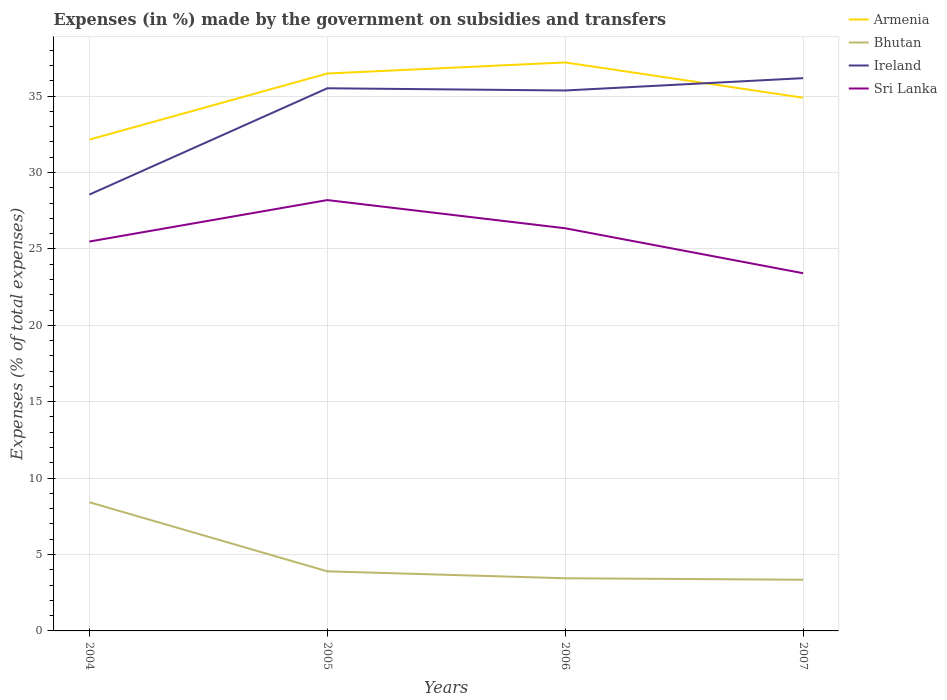How many different coloured lines are there?
Provide a succinct answer. 4. Does the line corresponding to Sri Lanka intersect with the line corresponding to Armenia?
Ensure brevity in your answer.  No. Is the number of lines equal to the number of legend labels?
Give a very brief answer. Yes. Across all years, what is the maximum percentage of expenses made by the government on subsidies and transfers in Ireland?
Provide a succinct answer. 28.56. In which year was the percentage of expenses made by the government on subsidies and transfers in Ireland maximum?
Provide a short and direct response. 2004. What is the total percentage of expenses made by the government on subsidies and transfers in Armenia in the graph?
Ensure brevity in your answer.  -2.74. What is the difference between the highest and the second highest percentage of expenses made by the government on subsidies and transfers in Bhutan?
Your answer should be very brief. 5.07. How many lines are there?
Give a very brief answer. 4. How many years are there in the graph?
Provide a short and direct response. 4. Does the graph contain any zero values?
Your response must be concise. No. Does the graph contain grids?
Your answer should be very brief. Yes. Where does the legend appear in the graph?
Offer a terse response. Top right. How many legend labels are there?
Your answer should be compact. 4. What is the title of the graph?
Keep it short and to the point. Expenses (in %) made by the government on subsidies and transfers. What is the label or title of the X-axis?
Ensure brevity in your answer.  Years. What is the label or title of the Y-axis?
Your answer should be compact. Expenses (% of total expenses). What is the Expenses (% of total expenses) of Armenia in 2004?
Your response must be concise. 32.15. What is the Expenses (% of total expenses) of Bhutan in 2004?
Give a very brief answer. 8.42. What is the Expenses (% of total expenses) of Ireland in 2004?
Offer a terse response. 28.56. What is the Expenses (% of total expenses) in Sri Lanka in 2004?
Your response must be concise. 25.48. What is the Expenses (% of total expenses) in Armenia in 2005?
Your response must be concise. 36.48. What is the Expenses (% of total expenses) in Bhutan in 2005?
Your answer should be compact. 3.9. What is the Expenses (% of total expenses) in Ireland in 2005?
Make the answer very short. 35.51. What is the Expenses (% of total expenses) in Sri Lanka in 2005?
Make the answer very short. 28.2. What is the Expenses (% of total expenses) in Armenia in 2006?
Offer a terse response. 37.2. What is the Expenses (% of total expenses) of Bhutan in 2006?
Offer a terse response. 3.45. What is the Expenses (% of total expenses) of Ireland in 2006?
Your answer should be very brief. 35.37. What is the Expenses (% of total expenses) of Sri Lanka in 2006?
Keep it short and to the point. 26.35. What is the Expenses (% of total expenses) of Armenia in 2007?
Give a very brief answer. 34.89. What is the Expenses (% of total expenses) in Bhutan in 2007?
Offer a terse response. 3.35. What is the Expenses (% of total expenses) in Ireland in 2007?
Offer a very short reply. 36.18. What is the Expenses (% of total expenses) in Sri Lanka in 2007?
Provide a succinct answer. 23.41. Across all years, what is the maximum Expenses (% of total expenses) in Armenia?
Make the answer very short. 37.2. Across all years, what is the maximum Expenses (% of total expenses) of Bhutan?
Give a very brief answer. 8.42. Across all years, what is the maximum Expenses (% of total expenses) of Ireland?
Provide a short and direct response. 36.18. Across all years, what is the maximum Expenses (% of total expenses) of Sri Lanka?
Offer a very short reply. 28.2. Across all years, what is the minimum Expenses (% of total expenses) of Armenia?
Your answer should be compact. 32.15. Across all years, what is the minimum Expenses (% of total expenses) of Bhutan?
Make the answer very short. 3.35. Across all years, what is the minimum Expenses (% of total expenses) in Ireland?
Provide a short and direct response. 28.56. Across all years, what is the minimum Expenses (% of total expenses) of Sri Lanka?
Offer a very short reply. 23.41. What is the total Expenses (% of total expenses) of Armenia in the graph?
Provide a short and direct response. 140.73. What is the total Expenses (% of total expenses) in Bhutan in the graph?
Give a very brief answer. 19.12. What is the total Expenses (% of total expenses) of Ireland in the graph?
Your answer should be compact. 135.62. What is the total Expenses (% of total expenses) of Sri Lanka in the graph?
Provide a succinct answer. 103.44. What is the difference between the Expenses (% of total expenses) of Armenia in 2004 and that in 2005?
Offer a terse response. -4.33. What is the difference between the Expenses (% of total expenses) in Bhutan in 2004 and that in 2005?
Your answer should be compact. 4.52. What is the difference between the Expenses (% of total expenses) in Ireland in 2004 and that in 2005?
Offer a very short reply. -6.96. What is the difference between the Expenses (% of total expenses) in Sri Lanka in 2004 and that in 2005?
Give a very brief answer. -2.71. What is the difference between the Expenses (% of total expenses) in Armenia in 2004 and that in 2006?
Your response must be concise. -5.05. What is the difference between the Expenses (% of total expenses) in Bhutan in 2004 and that in 2006?
Your response must be concise. 4.98. What is the difference between the Expenses (% of total expenses) in Ireland in 2004 and that in 2006?
Provide a short and direct response. -6.81. What is the difference between the Expenses (% of total expenses) in Sri Lanka in 2004 and that in 2006?
Ensure brevity in your answer.  -0.87. What is the difference between the Expenses (% of total expenses) in Armenia in 2004 and that in 2007?
Your answer should be compact. -2.74. What is the difference between the Expenses (% of total expenses) of Bhutan in 2004 and that in 2007?
Give a very brief answer. 5.07. What is the difference between the Expenses (% of total expenses) in Ireland in 2004 and that in 2007?
Provide a short and direct response. -7.62. What is the difference between the Expenses (% of total expenses) in Sri Lanka in 2004 and that in 2007?
Your answer should be compact. 2.07. What is the difference between the Expenses (% of total expenses) of Armenia in 2005 and that in 2006?
Provide a succinct answer. -0.73. What is the difference between the Expenses (% of total expenses) in Bhutan in 2005 and that in 2006?
Your answer should be very brief. 0.45. What is the difference between the Expenses (% of total expenses) of Ireland in 2005 and that in 2006?
Keep it short and to the point. 0.14. What is the difference between the Expenses (% of total expenses) of Sri Lanka in 2005 and that in 2006?
Offer a very short reply. 1.84. What is the difference between the Expenses (% of total expenses) in Armenia in 2005 and that in 2007?
Provide a short and direct response. 1.58. What is the difference between the Expenses (% of total expenses) in Bhutan in 2005 and that in 2007?
Keep it short and to the point. 0.55. What is the difference between the Expenses (% of total expenses) in Ireland in 2005 and that in 2007?
Keep it short and to the point. -0.66. What is the difference between the Expenses (% of total expenses) in Sri Lanka in 2005 and that in 2007?
Offer a very short reply. 4.79. What is the difference between the Expenses (% of total expenses) of Armenia in 2006 and that in 2007?
Offer a very short reply. 2.31. What is the difference between the Expenses (% of total expenses) of Bhutan in 2006 and that in 2007?
Make the answer very short. 0.1. What is the difference between the Expenses (% of total expenses) in Ireland in 2006 and that in 2007?
Your answer should be very brief. -0.81. What is the difference between the Expenses (% of total expenses) in Sri Lanka in 2006 and that in 2007?
Your response must be concise. 2.94. What is the difference between the Expenses (% of total expenses) in Armenia in 2004 and the Expenses (% of total expenses) in Bhutan in 2005?
Give a very brief answer. 28.25. What is the difference between the Expenses (% of total expenses) in Armenia in 2004 and the Expenses (% of total expenses) in Ireland in 2005?
Give a very brief answer. -3.36. What is the difference between the Expenses (% of total expenses) in Armenia in 2004 and the Expenses (% of total expenses) in Sri Lanka in 2005?
Your answer should be very brief. 3.96. What is the difference between the Expenses (% of total expenses) in Bhutan in 2004 and the Expenses (% of total expenses) in Ireland in 2005?
Provide a short and direct response. -27.09. What is the difference between the Expenses (% of total expenses) of Bhutan in 2004 and the Expenses (% of total expenses) of Sri Lanka in 2005?
Ensure brevity in your answer.  -19.77. What is the difference between the Expenses (% of total expenses) in Ireland in 2004 and the Expenses (% of total expenses) in Sri Lanka in 2005?
Offer a terse response. 0.36. What is the difference between the Expenses (% of total expenses) of Armenia in 2004 and the Expenses (% of total expenses) of Bhutan in 2006?
Make the answer very short. 28.71. What is the difference between the Expenses (% of total expenses) of Armenia in 2004 and the Expenses (% of total expenses) of Ireland in 2006?
Give a very brief answer. -3.22. What is the difference between the Expenses (% of total expenses) in Armenia in 2004 and the Expenses (% of total expenses) in Sri Lanka in 2006?
Give a very brief answer. 5.8. What is the difference between the Expenses (% of total expenses) in Bhutan in 2004 and the Expenses (% of total expenses) in Ireland in 2006?
Your response must be concise. -26.95. What is the difference between the Expenses (% of total expenses) in Bhutan in 2004 and the Expenses (% of total expenses) in Sri Lanka in 2006?
Your response must be concise. -17.93. What is the difference between the Expenses (% of total expenses) of Ireland in 2004 and the Expenses (% of total expenses) of Sri Lanka in 2006?
Your answer should be very brief. 2.21. What is the difference between the Expenses (% of total expenses) in Armenia in 2004 and the Expenses (% of total expenses) in Bhutan in 2007?
Offer a very short reply. 28.8. What is the difference between the Expenses (% of total expenses) in Armenia in 2004 and the Expenses (% of total expenses) in Ireland in 2007?
Your answer should be very brief. -4.02. What is the difference between the Expenses (% of total expenses) of Armenia in 2004 and the Expenses (% of total expenses) of Sri Lanka in 2007?
Give a very brief answer. 8.74. What is the difference between the Expenses (% of total expenses) in Bhutan in 2004 and the Expenses (% of total expenses) in Ireland in 2007?
Make the answer very short. -27.75. What is the difference between the Expenses (% of total expenses) of Bhutan in 2004 and the Expenses (% of total expenses) of Sri Lanka in 2007?
Provide a succinct answer. -14.99. What is the difference between the Expenses (% of total expenses) in Ireland in 2004 and the Expenses (% of total expenses) in Sri Lanka in 2007?
Ensure brevity in your answer.  5.15. What is the difference between the Expenses (% of total expenses) of Armenia in 2005 and the Expenses (% of total expenses) of Bhutan in 2006?
Offer a terse response. 33.03. What is the difference between the Expenses (% of total expenses) in Armenia in 2005 and the Expenses (% of total expenses) in Ireland in 2006?
Your answer should be very brief. 1.11. What is the difference between the Expenses (% of total expenses) in Armenia in 2005 and the Expenses (% of total expenses) in Sri Lanka in 2006?
Keep it short and to the point. 10.13. What is the difference between the Expenses (% of total expenses) of Bhutan in 2005 and the Expenses (% of total expenses) of Ireland in 2006?
Make the answer very short. -31.47. What is the difference between the Expenses (% of total expenses) of Bhutan in 2005 and the Expenses (% of total expenses) of Sri Lanka in 2006?
Your response must be concise. -22.45. What is the difference between the Expenses (% of total expenses) in Ireland in 2005 and the Expenses (% of total expenses) in Sri Lanka in 2006?
Make the answer very short. 9.16. What is the difference between the Expenses (% of total expenses) in Armenia in 2005 and the Expenses (% of total expenses) in Bhutan in 2007?
Provide a short and direct response. 33.13. What is the difference between the Expenses (% of total expenses) of Armenia in 2005 and the Expenses (% of total expenses) of Ireland in 2007?
Provide a succinct answer. 0.3. What is the difference between the Expenses (% of total expenses) in Armenia in 2005 and the Expenses (% of total expenses) in Sri Lanka in 2007?
Provide a succinct answer. 13.07. What is the difference between the Expenses (% of total expenses) of Bhutan in 2005 and the Expenses (% of total expenses) of Ireland in 2007?
Provide a succinct answer. -32.28. What is the difference between the Expenses (% of total expenses) of Bhutan in 2005 and the Expenses (% of total expenses) of Sri Lanka in 2007?
Give a very brief answer. -19.51. What is the difference between the Expenses (% of total expenses) of Ireland in 2005 and the Expenses (% of total expenses) of Sri Lanka in 2007?
Offer a very short reply. 12.1. What is the difference between the Expenses (% of total expenses) in Armenia in 2006 and the Expenses (% of total expenses) in Bhutan in 2007?
Make the answer very short. 33.85. What is the difference between the Expenses (% of total expenses) of Armenia in 2006 and the Expenses (% of total expenses) of Ireland in 2007?
Offer a terse response. 1.03. What is the difference between the Expenses (% of total expenses) in Armenia in 2006 and the Expenses (% of total expenses) in Sri Lanka in 2007?
Offer a terse response. 13.79. What is the difference between the Expenses (% of total expenses) of Bhutan in 2006 and the Expenses (% of total expenses) of Ireland in 2007?
Provide a short and direct response. -32.73. What is the difference between the Expenses (% of total expenses) of Bhutan in 2006 and the Expenses (% of total expenses) of Sri Lanka in 2007?
Offer a very short reply. -19.96. What is the difference between the Expenses (% of total expenses) of Ireland in 2006 and the Expenses (% of total expenses) of Sri Lanka in 2007?
Keep it short and to the point. 11.96. What is the average Expenses (% of total expenses) of Armenia per year?
Give a very brief answer. 35.18. What is the average Expenses (% of total expenses) in Bhutan per year?
Provide a succinct answer. 4.78. What is the average Expenses (% of total expenses) of Ireland per year?
Your answer should be very brief. 33.9. What is the average Expenses (% of total expenses) in Sri Lanka per year?
Provide a short and direct response. 25.86. In the year 2004, what is the difference between the Expenses (% of total expenses) in Armenia and Expenses (% of total expenses) in Bhutan?
Offer a very short reply. 23.73. In the year 2004, what is the difference between the Expenses (% of total expenses) of Armenia and Expenses (% of total expenses) of Ireland?
Give a very brief answer. 3.6. In the year 2004, what is the difference between the Expenses (% of total expenses) in Armenia and Expenses (% of total expenses) in Sri Lanka?
Keep it short and to the point. 6.67. In the year 2004, what is the difference between the Expenses (% of total expenses) of Bhutan and Expenses (% of total expenses) of Ireland?
Provide a short and direct response. -20.14. In the year 2004, what is the difference between the Expenses (% of total expenses) of Bhutan and Expenses (% of total expenses) of Sri Lanka?
Offer a terse response. -17.06. In the year 2004, what is the difference between the Expenses (% of total expenses) in Ireland and Expenses (% of total expenses) in Sri Lanka?
Offer a very short reply. 3.07. In the year 2005, what is the difference between the Expenses (% of total expenses) in Armenia and Expenses (% of total expenses) in Bhutan?
Offer a very short reply. 32.58. In the year 2005, what is the difference between the Expenses (% of total expenses) in Armenia and Expenses (% of total expenses) in Ireland?
Your answer should be compact. 0.97. In the year 2005, what is the difference between the Expenses (% of total expenses) of Armenia and Expenses (% of total expenses) of Sri Lanka?
Offer a very short reply. 8.28. In the year 2005, what is the difference between the Expenses (% of total expenses) of Bhutan and Expenses (% of total expenses) of Ireland?
Your answer should be compact. -31.61. In the year 2005, what is the difference between the Expenses (% of total expenses) of Bhutan and Expenses (% of total expenses) of Sri Lanka?
Give a very brief answer. -24.3. In the year 2005, what is the difference between the Expenses (% of total expenses) in Ireland and Expenses (% of total expenses) in Sri Lanka?
Provide a short and direct response. 7.32. In the year 2006, what is the difference between the Expenses (% of total expenses) of Armenia and Expenses (% of total expenses) of Bhutan?
Your response must be concise. 33.76. In the year 2006, what is the difference between the Expenses (% of total expenses) in Armenia and Expenses (% of total expenses) in Ireland?
Your response must be concise. 1.84. In the year 2006, what is the difference between the Expenses (% of total expenses) of Armenia and Expenses (% of total expenses) of Sri Lanka?
Offer a terse response. 10.85. In the year 2006, what is the difference between the Expenses (% of total expenses) of Bhutan and Expenses (% of total expenses) of Ireland?
Provide a succinct answer. -31.92. In the year 2006, what is the difference between the Expenses (% of total expenses) of Bhutan and Expenses (% of total expenses) of Sri Lanka?
Your response must be concise. -22.91. In the year 2006, what is the difference between the Expenses (% of total expenses) of Ireland and Expenses (% of total expenses) of Sri Lanka?
Keep it short and to the point. 9.02. In the year 2007, what is the difference between the Expenses (% of total expenses) of Armenia and Expenses (% of total expenses) of Bhutan?
Make the answer very short. 31.55. In the year 2007, what is the difference between the Expenses (% of total expenses) of Armenia and Expenses (% of total expenses) of Ireland?
Your answer should be compact. -1.28. In the year 2007, what is the difference between the Expenses (% of total expenses) of Armenia and Expenses (% of total expenses) of Sri Lanka?
Your answer should be very brief. 11.48. In the year 2007, what is the difference between the Expenses (% of total expenses) of Bhutan and Expenses (% of total expenses) of Ireland?
Offer a terse response. -32.83. In the year 2007, what is the difference between the Expenses (% of total expenses) of Bhutan and Expenses (% of total expenses) of Sri Lanka?
Make the answer very short. -20.06. In the year 2007, what is the difference between the Expenses (% of total expenses) of Ireland and Expenses (% of total expenses) of Sri Lanka?
Offer a very short reply. 12.77. What is the ratio of the Expenses (% of total expenses) in Armenia in 2004 to that in 2005?
Your answer should be compact. 0.88. What is the ratio of the Expenses (% of total expenses) of Bhutan in 2004 to that in 2005?
Your answer should be compact. 2.16. What is the ratio of the Expenses (% of total expenses) of Ireland in 2004 to that in 2005?
Provide a succinct answer. 0.8. What is the ratio of the Expenses (% of total expenses) in Sri Lanka in 2004 to that in 2005?
Your response must be concise. 0.9. What is the ratio of the Expenses (% of total expenses) in Armenia in 2004 to that in 2006?
Your response must be concise. 0.86. What is the ratio of the Expenses (% of total expenses) in Bhutan in 2004 to that in 2006?
Offer a terse response. 2.44. What is the ratio of the Expenses (% of total expenses) in Ireland in 2004 to that in 2006?
Offer a terse response. 0.81. What is the ratio of the Expenses (% of total expenses) in Sri Lanka in 2004 to that in 2006?
Your response must be concise. 0.97. What is the ratio of the Expenses (% of total expenses) in Armenia in 2004 to that in 2007?
Offer a terse response. 0.92. What is the ratio of the Expenses (% of total expenses) in Bhutan in 2004 to that in 2007?
Your answer should be compact. 2.51. What is the ratio of the Expenses (% of total expenses) in Ireland in 2004 to that in 2007?
Ensure brevity in your answer.  0.79. What is the ratio of the Expenses (% of total expenses) of Sri Lanka in 2004 to that in 2007?
Provide a succinct answer. 1.09. What is the ratio of the Expenses (% of total expenses) of Armenia in 2005 to that in 2006?
Your answer should be compact. 0.98. What is the ratio of the Expenses (% of total expenses) in Bhutan in 2005 to that in 2006?
Your answer should be very brief. 1.13. What is the ratio of the Expenses (% of total expenses) of Sri Lanka in 2005 to that in 2006?
Your answer should be very brief. 1.07. What is the ratio of the Expenses (% of total expenses) in Armenia in 2005 to that in 2007?
Your response must be concise. 1.05. What is the ratio of the Expenses (% of total expenses) of Bhutan in 2005 to that in 2007?
Give a very brief answer. 1.16. What is the ratio of the Expenses (% of total expenses) of Ireland in 2005 to that in 2007?
Provide a short and direct response. 0.98. What is the ratio of the Expenses (% of total expenses) of Sri Lanka in 2005 to that in 2007?
Ensure brevity in your answer.  1.2. What is the ratio of the Expenses (% of total expenses) in Armenia in 2006 to that in 2007?
Make the answer very short. 1.07. What is the ratio of the Expenses (% of total expenses) of Bhutan in 2006 to that in 2007?
Provide a succinct answer. 1.03. What is the ratio of the Expenses (% of total expenses) of Ireland in 2006 to that in 2007?
Your answer should be compact. 0.98. What is the ratio of the Expenses (% of total expenses) of Sri Lanka in 2006 to that in 2007?
Your answer should be very brief. 1.13. What is the difference between the highest and the second highest Expenses (% of total expenses) of Armenia?
Make the answer very short. 0.73. What is the difference between the highest and the second highest Expenses (% of total expenses) of Bhutan?
Offer a very short reply. 4.52. What is the difference between the highest and the second highest Expenses (% of total expenses) of Ireland?
Keep it short and to the point. 0.66. What is the difference between the highest and the second highest Expenses (% of total expenses) in Sri Lanka?
Offer a terse response. 1.84. What is the difference between the highest and the lowest Expenses (% of total expenses) of Armenia?
Ensure brevity in your answer.  5.05. What is the difference between the highest and the lowest Expenses (% of total expenses) in Bhutan?
Offer a terse response. 5.07. What is the difference between the highest and the lowest Expenses (% of total expenses) in Ireland?
Provide a short and direct response. 7.62. What is the difference between the highest and the lowest Expenses (% of total expenses) in Sri Lanka?
Offer a very short reply. 4.79. 